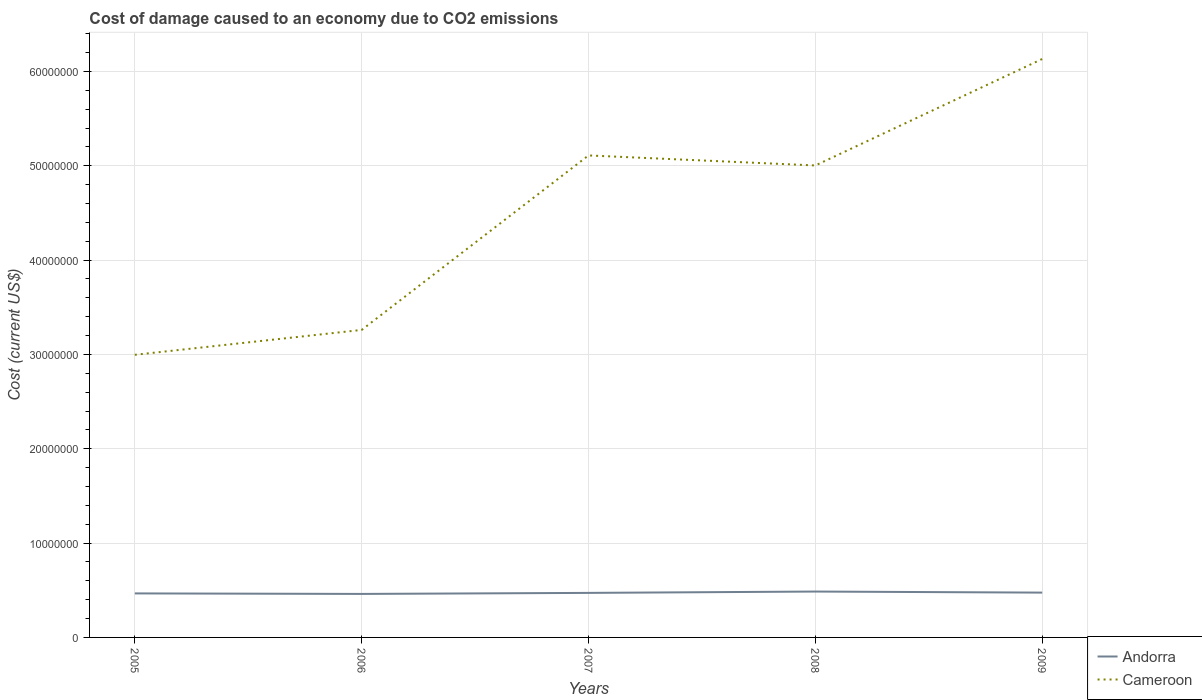Is the number of lines equal to the number of legend labels?
Your answer should be compact. Yes. Across all years, what is the maximum cost of damage caused due to CO2 emissisons in Andorra?
Offer a terse response. 4.61e+06. In which year was the cost of damage caused due to CO2 emissisons in Andorra maximum?
Provide a succinct answer. 2006. What is the total cost of damage caused due to CO2 emissisons in Andorra in the graph?
Keep it short and to the point. 1.14e+05. What is the difference between the highest and the second highest cost of damage caused due to CO2 emissisons in Cameroon?
Ensure brevity in your answer.  3.14e+07. Is the cost of damage caused due to CO2 emissisons in Cameroon strictly greater than the cost of damage caused due to CO2 emissisons in Andorra over the years?
Your answer should be very brief. No. How many years are there in the graph?
Your answer should be compact. 5. What is the difference between two consecutive major ticks on the Y-axis?
Offer a terse response. 1.00e+07. Are the values on the major ticks of Y-axis written in scientific E-notation?
Ensure brevity in your answer.  No. How many legend labels are there?
Provide a short and direct response. 2. What is the title of the graph?
Ensure brevity in your answer.  Cost of damage caused to an economy due to CO2 emissions. Does "Hong Kong" appear as one of the legend labels in the graph?
Your response must be concise. No. What is the label or title of the X-axis?
Provide a short and direct response. Years. What is the label or title of the Y-axis?
Provide a succinct answer. Cost (current US$). What is the Cost (current US$) in Andorra in 2005?
Offer a very short reply. 4.67e+06. What is the Cost (current US$) in Cameroon in 2005?
Provide a succinct answer. 3.00e+07. What is the Cost (current US$) of Andorra in 2006?
Provide a succinct answer. 4.61e+06. What is the Cost (current US$) of Cameroon in 2006?
Provide a succinct answer. 3.26e+07. What is the Cost (current US$) in Andorra in 2007?
Give a very brief answer. 4.72e+06. What is the Cost (current US$) in Cameroon in 2007?
Your response must be concise. 5.11e+07. What is the Cost (current US$) of Andorra in 2008?
Your response must be concise. 4.86e+06. What is the Cost (current US$) of Cameroon in 2008?
Your response must be concise. 5.00e+07. What is the Cost (current US$) in Andorra in 2009?
Offer a very short reply. 4.75e+06. What is the Cost (current US$) in Cameroon in 2009?
Give a very brief answer. 6.13e+07. Across all years, what is the maximum Cost (current US$) of Andorra?
Your response must be concise. 4.86e+06. Across all years, what is the maximum Cost (current US$) of Cameroon?
Provide a succinct answer. 6.13e+07. Across all years, what is the minimum Cost (current US$) in Andorra?
Your answer should be compact. 4.61e+06. Across all years, what is the minimum Cost (current US$) of Cameroon?
Ensure brevity in your answer.  3.00e+07. What is the total Cost (current US$) in Andorra in the graph?
Your answer should be very brief. 2.36e+07. What is the total Cost (current US$) of Cameroon in the graph?
Offer a terse response. 2.25e+08. What is the difference between the Cost (current US$) of Andorra in 2005 and that in 2006?
Ensure brevity in your answer.  5.37e+04. What is the difference between the Cost (current US$) of Cameroon in 2005 and that in 2006?
Provide a succinct answer. -2.64e+06. What is the difference between the Cost (current US$) of Andorra in 2005 and that in 2007?
Make the answer very short. -5.46e+04. What is the difference between the Cost (current US$) in Cameroon in 2005 and that in 2007?
Provide a short and direct response. -2.11e+07. What is the difference between the Cost (current US$) of Andorra in 2005 and that in 2008?
Your answer should be very brief. -1.98e+05. What is the difference between the Cost (current US$) in Cameroon in 2005 and that in 2008?
Your answer should be compact. -2.01e+07. What is the difference between the Cost (current US$) in Andorra in 2005 and that in 2009?
Offer a very short reply. -8.41e+04. What is the difference between the Cost (current US$) in Cameroon in 2005 and that in 2009?
Offer a terse response. -3.14e+07. What is the difference between the Cost (current US$) of Andorra in 2006 and that in 2007?
Give a very brief answer. -1.08e+05. What is the difference between the Cost (current US$) in Cameroon in 2006 and that in 2007?
Offer a terse response. -1.85e+07. What is the difference between the Cost (current US$) in Andorra in 2006 and that in 2008?
Your answer should be compact. -2.52e+05. What is the difference between the Cost (current US$) of Cameroon in 2006 and that in 2008?
Your response must be concise. -1.74e+07. What is the difference between the Cost (current US$) of Andorra in 2006 and that in 2009?
Give a very brief answer. -1.38e+05. What is the difference between the Cost (current US$) in Cameroon in 2006 and that in 2009?
Offer a terse response. -2.87e+07. What is the difference between the Cost (current US$) of Andorra in 2007 and that in 2008?
Your answer should be compact. -1.43e+05. What is the difference between the Cost (current US$) of Cameroon in 2007 and that in 2008?
Offer a very short reply. 1.06e+06. What is the difference between the Cost (current US$) in Andorra in 2007 and that in 2009?
Ensure brevity in your answer.  -2.96e+04. What is the difference between the Cost (current US$) in Cameroon in 2007 and that in 2009?
Ensure brevity in your answer.  -1.02e+07. What is the difference between the Cost (current US$) of Andorra in 2008 and that in 2009?
Your response must be concise. 1.14e+05. What is the difference between the Cost (current US$) of Cameroon in 2008 and that in 2009?
Your answer should be very brief. -1.13e+07. What is the difference between the Cost (current US$) in Andorra in 2005 and the Cost (current US$) in Cameroon in 2006?
Your answer should be compact. -2.79e+07. What is the difference between the Cost (current US$) in Andorra in 2005 and the Cost (current US$) in Cameroon in 2007?
Offer a terse response. -4.64e+07. What is the difference between the Cost (current US$) of Andorra in 2005 and the Cost (current US$) of Cameroon in 2008?
Your response must be concise. -4.54e+07. What is the difference between the Cost (current US$) in Andorra in 2005 and the Cost (current US$) in Cameroon in 2009?
Your response must be concise. -5.67e+07. What is the difference between the Cost (current US$) of Andorra in 2006 and the Cost (current US$) of Cameroon in 2007?
Provide a succinct answer. -4.65e+07. What is the difference between the Cost (current US$) in Andorra in 2006 and the Cost (current US$) in Cameroon in 2008?
Offer a very short reply. -4.54e+07. What is the difference between the Cost (current US$) in Andorra in 2006 and the Cost (current US$) in Cameroon in 2009?
Keep it short and to the point. -5.67e+07. What is the difference between the Cost (current US$) of Andorra in 2007 and the Cost (current US$) of Cameroon in 2008?
Offer a very short reply. -4.53e+07. What is the difference between the Cost (current US$) of Andorra in 2007 and the Cost (current US$) of Cameroon in 2009?
Give a very brief answer. -5.66e+07. What is the difference between the Cost (current US$) in Andorra in 2008 and the Cost (current US$) in Cameroon in 2009?
Keep it short and to the point. -5.65e+07. What is the average Cost (current US$) in Andorra per year?
Offer a terse response. 4.72e+06. What is the average Cost (current US$) in Cameroon per year?
Your response must be concise. 4.50e+07. In the year 2005, what is the difference between the Cost (current US$) of Andorra and Cost (current US$) of Cameroon?
Give a very brief answer. -2.53e+07. In the year 2006, what is the difference between the Cost (current US$) of Andorra and Cost (current US$) of Cameroon?
Your answer should be very brief. -2.80e+07. In the year 2007, what is the difference between the Cost (current US$) of Andorra and Cost (current US$) of Cameroon?
Your answer should be compact. -4.64e+07. In the year 2008, what is the difference between the Cost (current US$) in Andorra and Cost (current US$) in Cameroon?
Provide a short and direct response. -4.52e+07. In the year 2009, what is the difference between the Cost (current US$) in Andorra and Cost (current US$) in Cameroon?
Your response must be concise. -5.66e+07. What is the ratio of the Cost (current US$) of Andorra in 2005 to that in 2006?
Your response must be concise. 1.01. What is the ratio of the Cost (current US$) of Cameroon in 2005 to that in 2006?
Keep it short and to the point. 0.92. What is the ratio of the Cost (current US$) of Andorra in 2005 to that in 2007?
Your answer should be very brief. 0.99. What is the ratio of the Cost (current US$) of Cameroon in 2005 to that in 2007?
Ensure brevity in your answer.  0.59. What is the ratio of the Cost (current US$) of Andorra in 2005 to that in 2008?
Offer a very short reply. 0.96. What is the ratio of the Cost (current US$) of Cameroon in 2005 to that in 2008?
Your answer should be compact. 0.6. What is the ratio of the Cost (current US$) of Andorra in 2005 to that in 2009?
Your answer should be very brief. 0.98. What is the ratio of the Cost (current US$) in Cameroon in 2005 to that in 2009?
Your answer should be very brief. 0.49. What is the ratio of the Cost (current US$) in Andorra in 2006 to that in 2007?
Offer a very short reply. 0.98. What is the ratio of the Cost (current US$) of Cameroon in 2006 to that in 2007?
Provide a short and direct response. 0.64. What is the ratio of the Cost (current US$) in Andorra in 2006 to that in 2008?
Give a very brief answer. 0.95. What is the ratio of the Cost (current US$) of Cameroon in 2006 to that in 2008?
Give a very brief answer. 0.65. What is the ratio of the Cost (current US$) of Andorra in 2006 to that in 2009?
Provide a succinct answer. 0.97. What is the ratio of the Cost (current US$) in Cameroon in 2006 to that in 2009?
Offer a very short reply. 0.53. What is the ratio of the Cost (current US$) of Andorra in 2007 to that in 2008?
Provide a succinct answer. 0.97. What is the ratio of the Cost (current US$) in Cameroon in 2007 to that in 2008?
Ensure brevity in your answer.  1.02. What is the ratio of the Cost (current US$) of Andorra in 2007 to that in 2009?
Keep it short and to the point. 0.99. What is the ratio of the Cost (current US$) of Andorra in 2008 to that in 2009?
Provide a short and direct response. 1.02. What is the ratio of the Cost (current US$) in Cameroon in 2008 to that in 2009?
Make the answer very short. 0.82. What is the difference between the highest and the second highest Cost (current US$) in Andorra?
Your answer should be very brief. 1.14e+05. What is the difference between the highest and the second highest Cost (current US$) in Cameroon?
Offer a very short reply. 1.02e+07. What is the difference between the highest and the lowest Cost (current US$) in Andorra?
Your answer should be compact. 2.52e+05. What is the difference between the highest and the lowest Cost (current US$) of Cameroon?
Make the answer very short. 3.14e+07. 